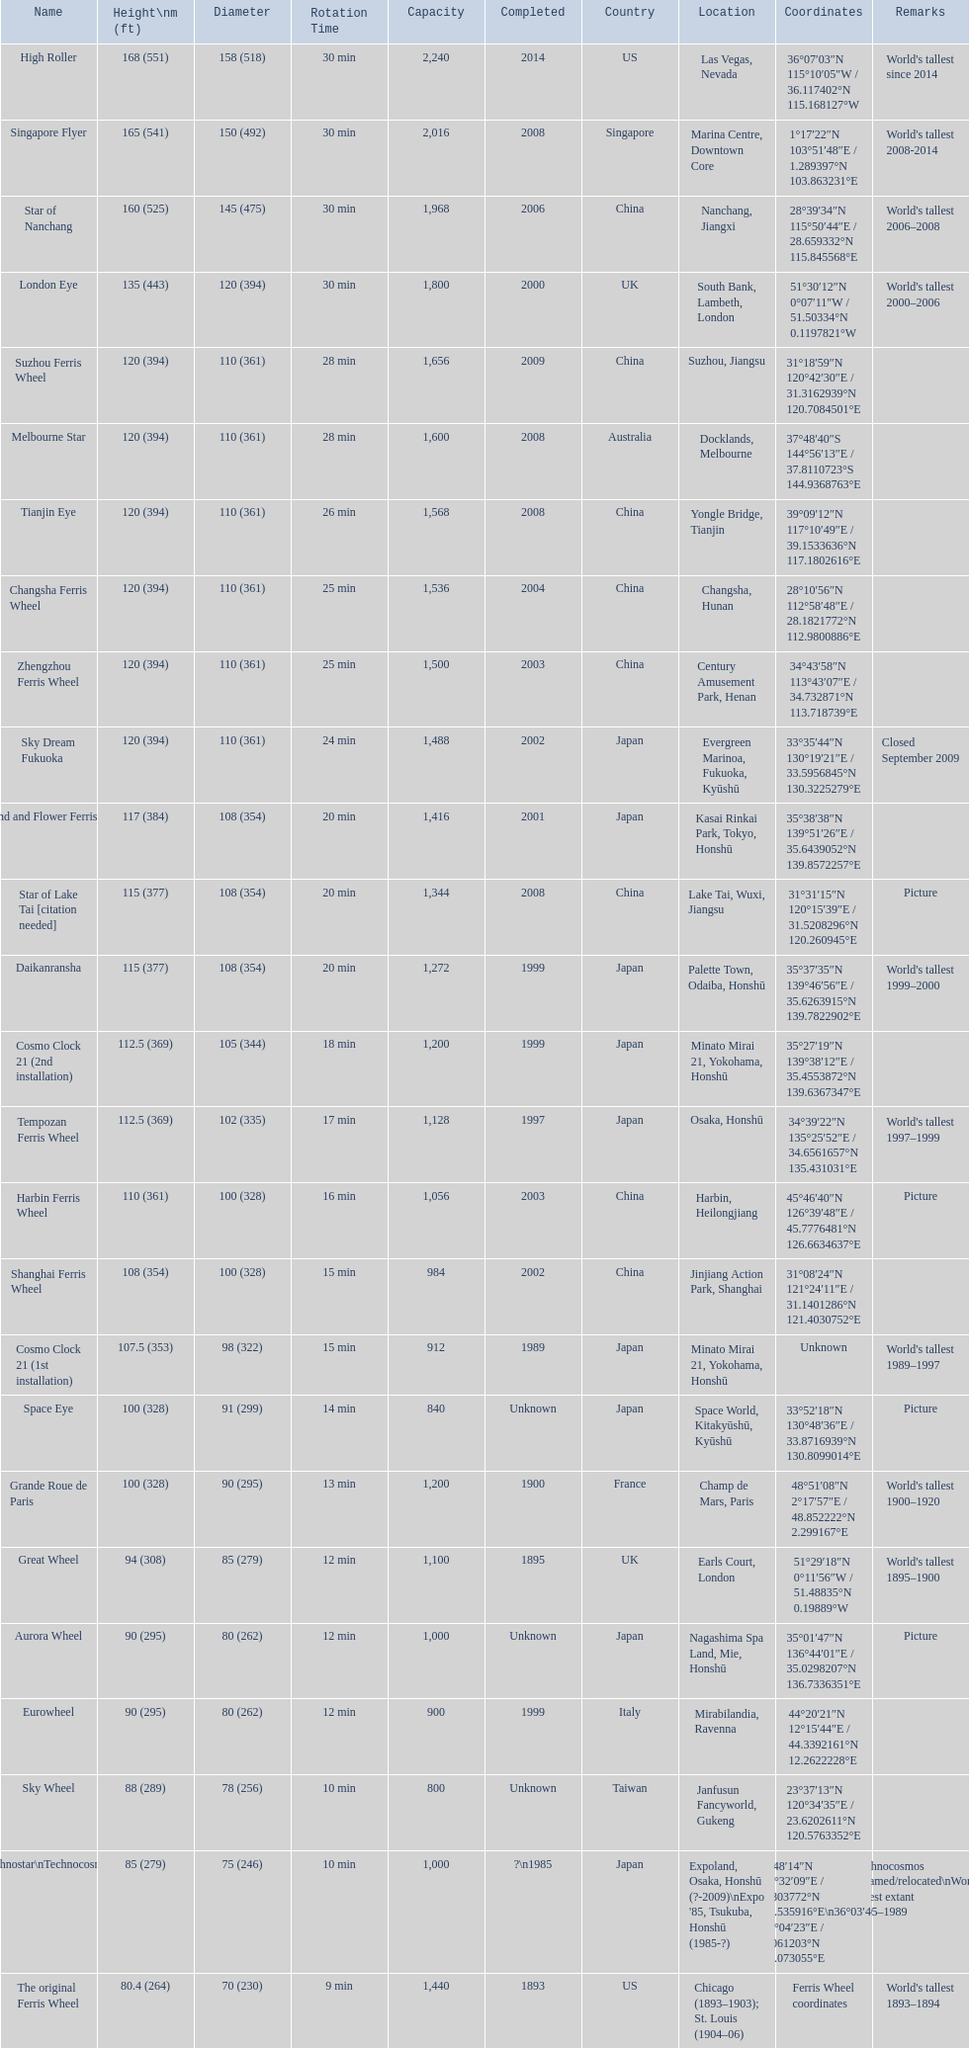How tall is the roller coaster star of nanchang? 165 (541). When was the roller coaster star of nanchang completed? 2008. What is the name of the oldest roller coaster? Star of Nanchang. 